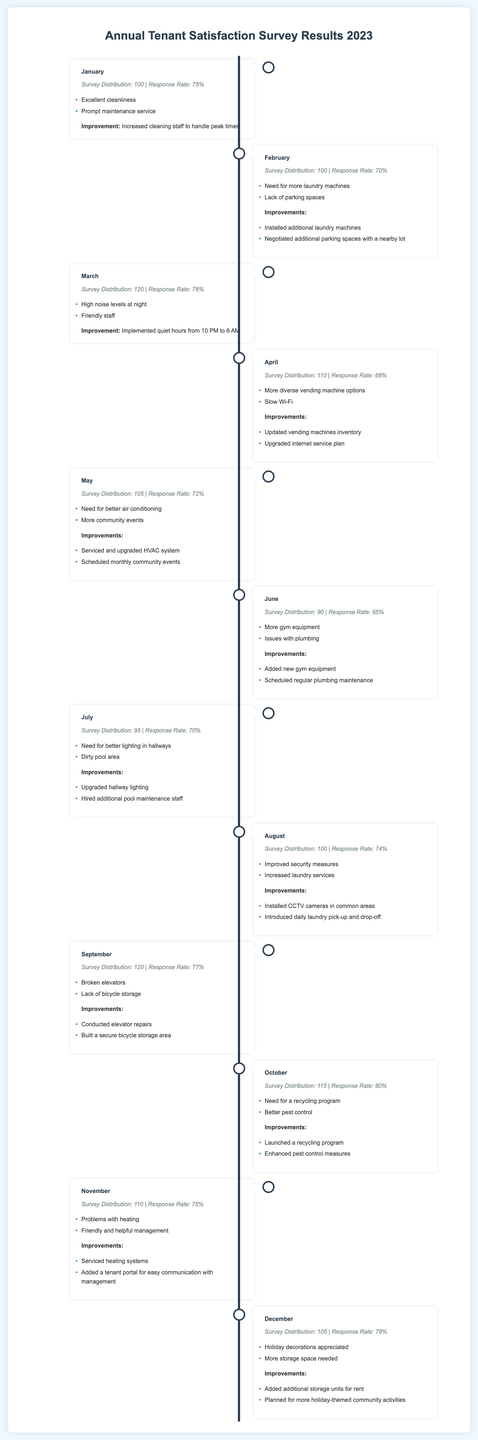What was the overall response rate in January? The response rate for January is directly indicated as 75%.
Answer: 75% Which month had the highest survey distribution? The highest survey distribution of 120 occurred in both March and September.
Answer: 120 What improvement was made in February? In February, additional laundry machines were installed as part of the improvements.
Answer: Installed additional laundry machines What was the common feedback in June? The common feedback in June included a need for more gym equipment and plumbing issues.
Answer: More gym equipment, plumbing issues How many surveys were distributed in October? The survey distribution for October is specified as 115.
Answer: 115 What major improvement was implemented in August? The significant improvement made in August was the installation of CCTV cameras in common areas.
Answer: Installed CCTV cameras in common areas Which month reported high noise levels at night? March included feedback regarding high noise levels at night according to the responses.
Answer: March What reason was given for having more community events? The feedback in May specifically mentioned a need for more community events.
Answer: More community events What change was made regarding heating problems in November? The improvement in November involved servicing heating systems to address the reported problems.
Answer: Serviced heating systems 